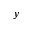Convert formula to latex. <formula><loc_0><loc_0><loc_500><loc_500>y</formula> 